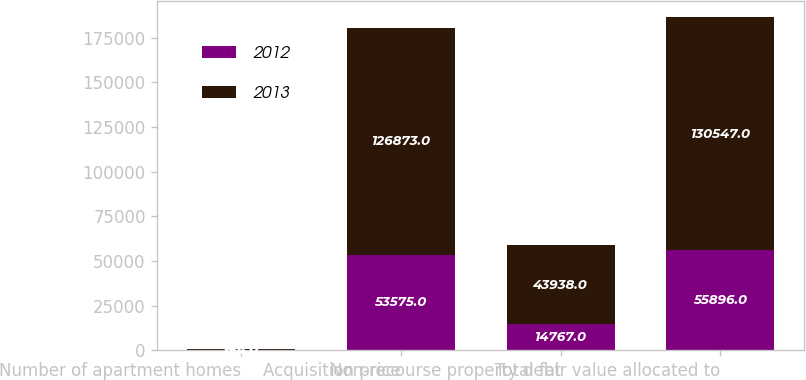Convert chart to OTSL. <chart><loc_0><loc_0><loc_500><loc_500><stacked_bar_chart><ecel><fcel>Number of apartment homes<fcel>Acquisition price<fcel>Non-recourse property debt<fcel>Total fair value allocated to<nl><fcel>2012<fcel>134<fcel>53575<fcel>14767<fcel>55896<nl><fcel>2013<fcel>614<fcel>126873<fcel>43938<fcel>130547<nl></chart> 